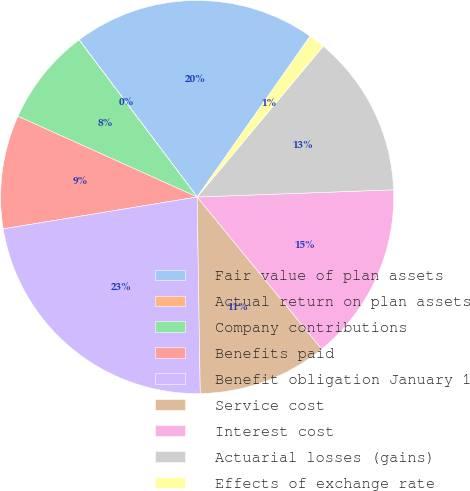Convert chart to OTSL. <chart><loc_0><loc_0><loc_500><loc_500><pie_chart><fcel>Fair value of plan assets<fcel>Actual return on plan assets<fcel>Company contributions<fcel>Benefits paid<fcel>Benefit obligation January 1<fcel>Service cost<fcel>Interest cost<fcel>Actuarial losses (gains)<fcel>Effects of exchange rate<nl><fcel>20.0%<fcel>0.01%<fcel>8.0%<fcel>9.33%<fcel>22.66%<fcel>10.67%<fcel>14.66%<fcel>13.33%<fcel>1.34%<nl></chart> 